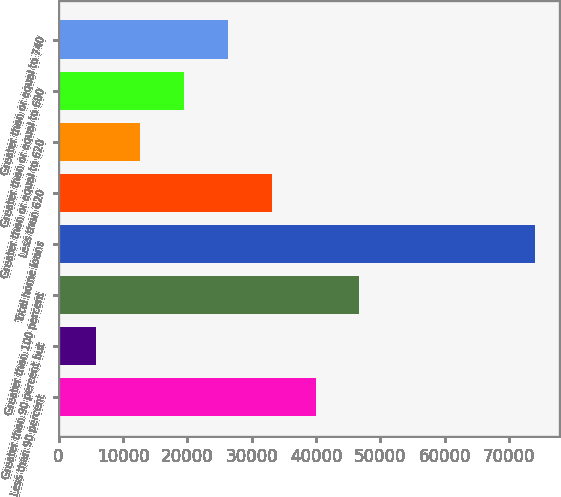Convert chart. <chart><loc_0><loc_0><loc_500><loc_500><bar_chart><fcel>Less than 90 percent<fcel>Greater than 90 percent but<fcel>Greater than 100 percent<fcel>Total home loans<fcel>Less than 620<fcel>Greater than or equal to 620<fcel>Greater than or equal to 680<fcel>Greater than or equal to 740<nl><fcel>39917<fcel>5847<fcel>46731<fcel>73987<fcel>33103<fcel>12661<fcel>19475<fcel>26289<nl></chart> 